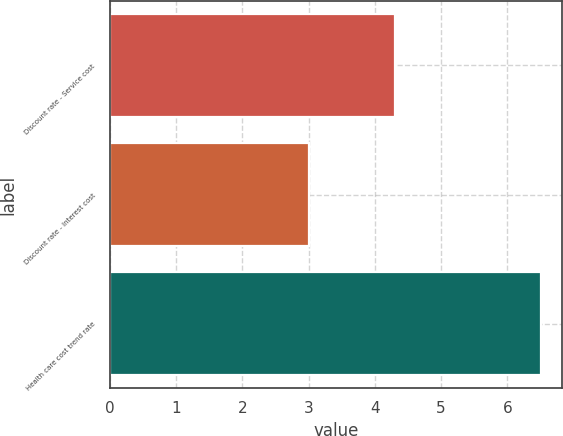Convert chart. <chart><loc_0><loc_0><loc_500><loc_500><bar_chart><fcel>Discount rate - Service cost<fcel>Discount rate - Interest cost<fcel>Health care cost trend rate<nl><fcel>4.3<fcel>3<fcel>6.5<nl></chart> 